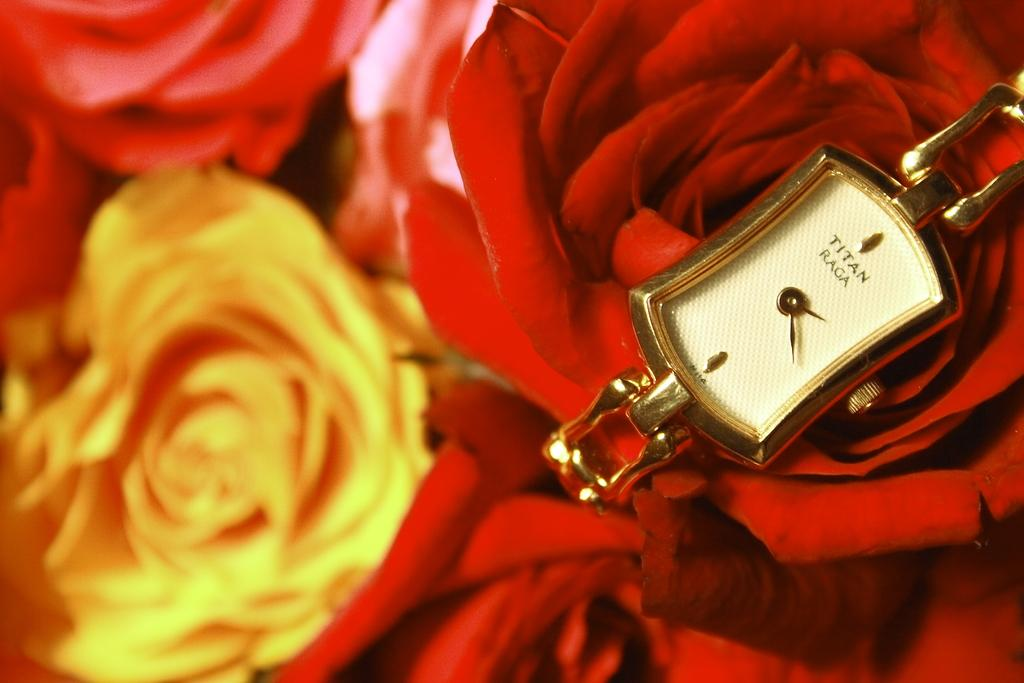<image>
Describe the image concisely. A gold watch says "TITAN RAGA" on the face. 